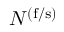Convert formula to latex. <formula><loc_0><loc_0><loc_500><loc_500>N _ { \ell } ^ { ( f / s ) }</formula> 